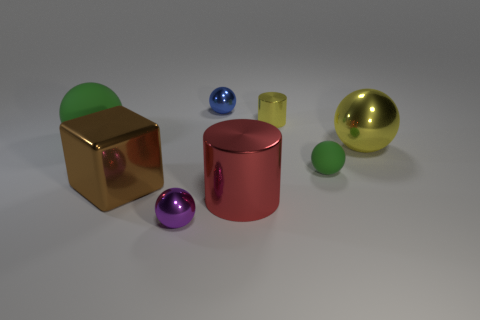Subtract all tiny shiny balls. How many balls are left? 3 Subtract all yellow cylinders. How many green balls are left? 2 Subtract all blue balls. How many balls are left? 4 Add 2 big brown things. How many objects exist? 10 Add 6 big brown spheres. How many big brown spheres exist? 6 Subtract 0 cyan cubes. How many objects are left? 8 Subtract all cubes. How many objects are left? 7 Subtract all yellow balls. Subtract all yellow cylinders. How many balls are left? 4 Subtract all large green objects. Subtract all big green things. How many objects are left? 6 Add 3 large shiny blocks. How many large shiny blocks are left? 4 